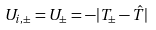Convert formula to latex. <formula><loc_0><loc_0><loc_500><loc_500>U _ { i , \pm } = U _ { \pm } = - | T _ { \pm } - \hat { T } |</formula> 